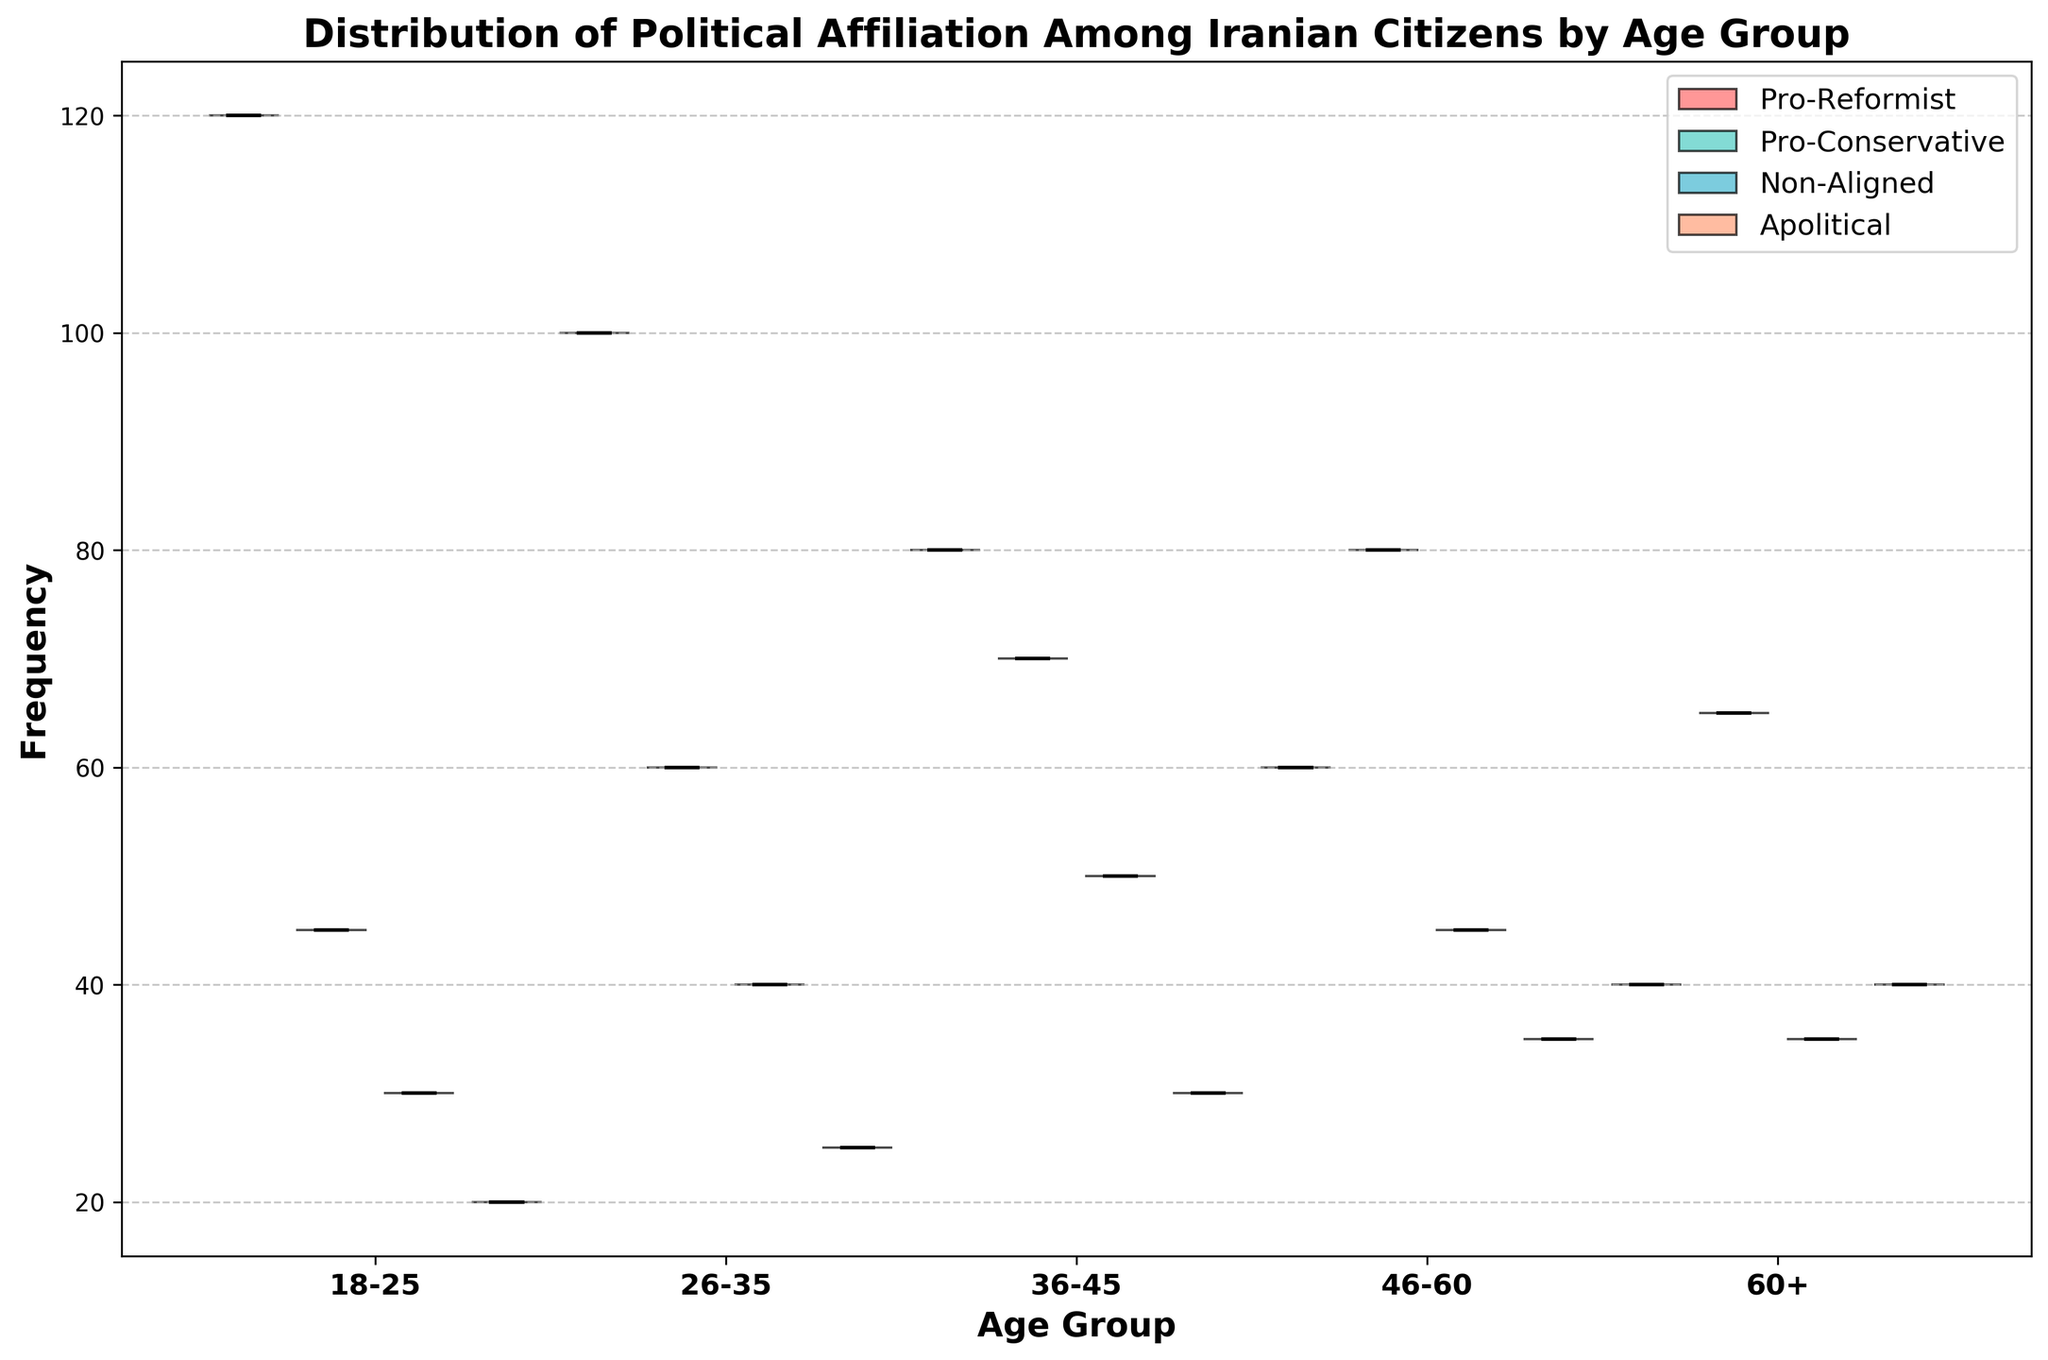What is the title of the chart? The title is usually displayed at the top of the chart. In this case, the title is "Distribution of Political Affiliation Among Iranian Citizens by Age Group."
Answer: Distribution of Political Affiliation Among Iranian Citizens by Age Group What age group has the highest frequency of pro-reformist affiliation? To find this, compare the widths of the violins for the pro-reformist affiliation (red color) across different age groups. The widest violin indicates the highest frequency.
Answer: 18-25 Which political affiliation appears most frequently in the 46-60 age group? Look at the violins in the 46-60 age group. The widest area represents the most frequent political affiliation.
Answer: Pro-Conservative How does the frequency of non-aligned individuals compare between the 18-25 and 60+ age groups? Compare the widths of the violins for non-aligned individuals (blue color) in the 18-25 and 60+ age groups.
Answer: 18-25 is wider than 60+ Which age group has the least number of apolitical individuals? Find the narrowest violin plot for apolitical individuals (orange color) across all age groups.
Answer: 18-25 What is the overall trend of pro-reformist affiliation as the age group increases? Examine the width of the violins for pro-reformist affiliation (red color) from the youngest age group to the oldest. The width represents frequency.
Answer: Decreases with age Which political affiliation shows the most significant increase in frequency from the 18-25 age group to the 46-60 age group? Compare the width of the violins for each political affiliation in the 18-25 and 46-60 age groups. Identify the affiliation with the most noticeable increase in width.
Answer: Pro-Conservative Is the frequency of apolitical individuals more evenly distributed across age groups compared to other affiliations? Evaluate the uniformity of the widths of the violins for apolitical individuals (orange color) across all age groups. Uneven distributions have significant variation in width among age groups.
Answer: Yes, more evenly distributed What is the median frequency of pro-conservative affiliation in the 26-35 age group? The median is indicated by a black line within the respective violin. Examine the violin for pro-conservative affiliation (green color) in the 26-35 age group and locate the black line.
Answer: 60 